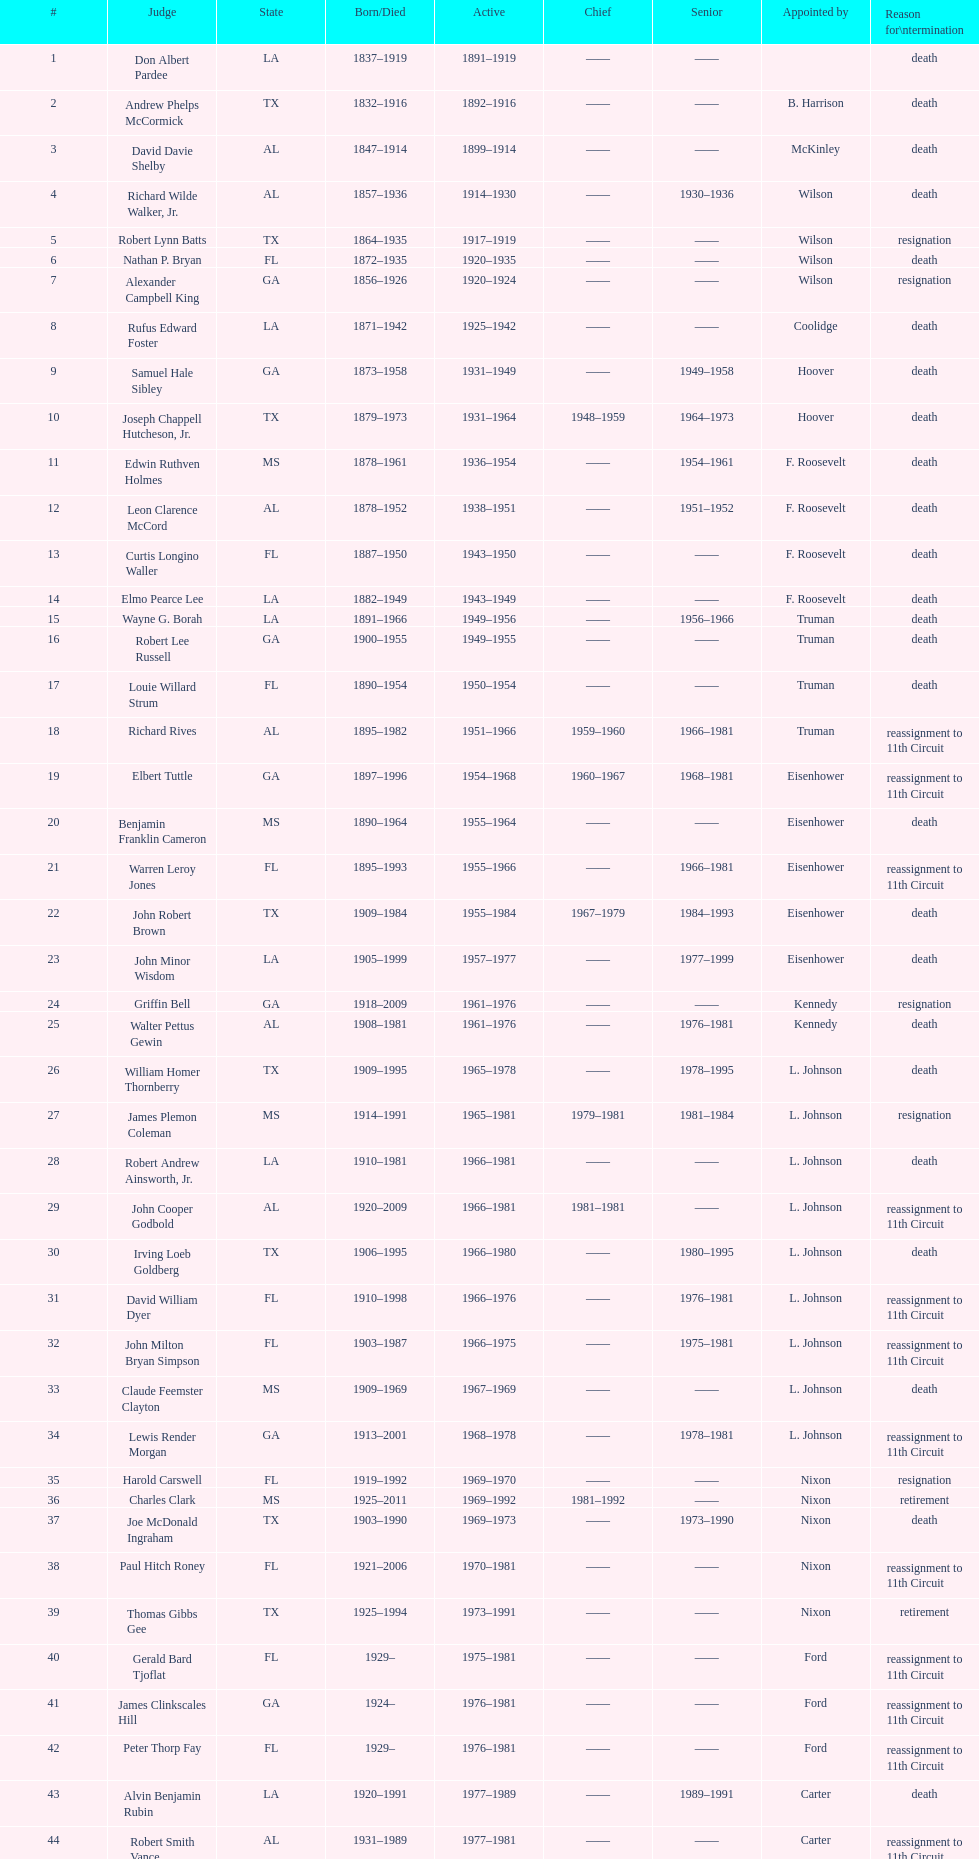How many judges have held the position of chief in total? 8. 